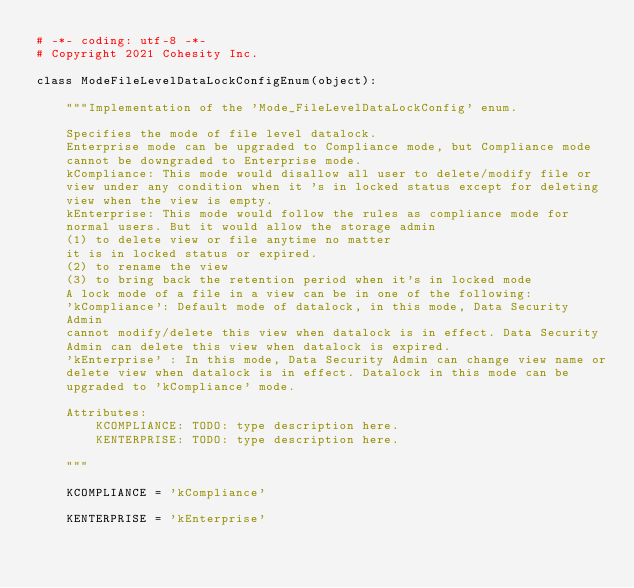<code> <loc_0><loc_0><loc_500><loc_500><_Python_># -*- coding: utf-8 -*-
# Copyright 2021 Cohesity Inc.

class ModeFileLevelDataLockConfigEnum(object):

    """Implementation of the 'Mode_FileLevelDataLockConfig' enum.

    Specifies the mode of file level datalock.
    Enterprise mode can be upgraded to Compliance mode, but Compliance mode
    cannot be downgraded to Enterprise mode.
    kCompliance: This mode would disallow all user to delete/modify file or
    view under any condition when it 's in locked status except for deleting
    view when the view is empty.
    kEnterprise: This mode would follow the rules as compliance mode for
    normal users. But it would allow the storage admin
    (1) to delete view or file anytime no matter
    it is in locked status or expired.
    (2) to rename the view
    (3) to bring back the retention period when it's in locked mode
    A lock mode of a file in a view can be in one of the following:
    'kCompliance': Default mode of datalock, in this mode, Data Security
    Admin
    cannot modify/delete this view when datalock is in effect. Data Security
    Admin can delete this view when datalock is expired.
    'kEnterprise' : In this mode, Data Security Admin can change view name or
    delete view when datalock is in effect. Datalock in this mode can be
    upgraded to 'kCompliance' mode.

    Attributes:
        KCOMPLIANCE: TODO: type description here.
        KENTERPRISE: TODO: type description here.

    """

    KCOMPLIANCE = 'kCompliance'

    KENTERPRISE = 'kEnterprise'

</code> 